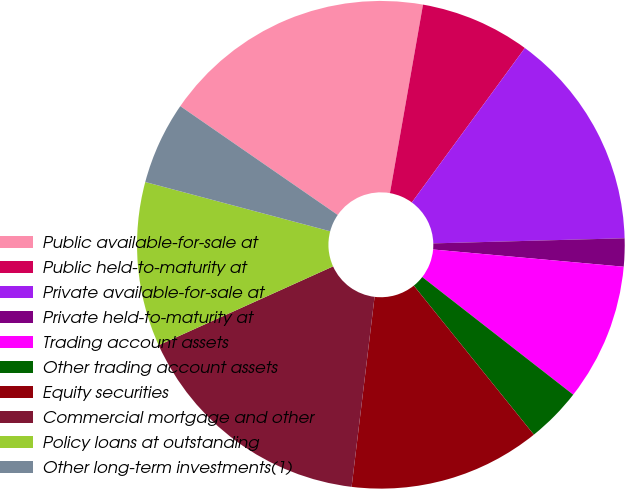Convert chart to OTSL. <chart><loc_0><loc_0><loc_500><loc_500><pie_chart><fcel>Public available-for-sale at<fcel>Public held-to-maturity at<fcel>Private available-for-sale at<fcel>Private held-to-maturity at<fcel>Trading account assets<fcel>Other trading account assets<fcel>Equity securities<fcel>Commercial mortgage and other<fcel>Policy loans at outstanding<fcel>Other long-term investments(1)<nl><fcel>18.14%<fcel>7.29%<fcel>14.52%<fcel>1.86%<fcel>9.1%<fcel>3.67%<fcel>12.71%<fcel>16.33%<fcel>10.9%<fcel>5.48%<nl></chart> 